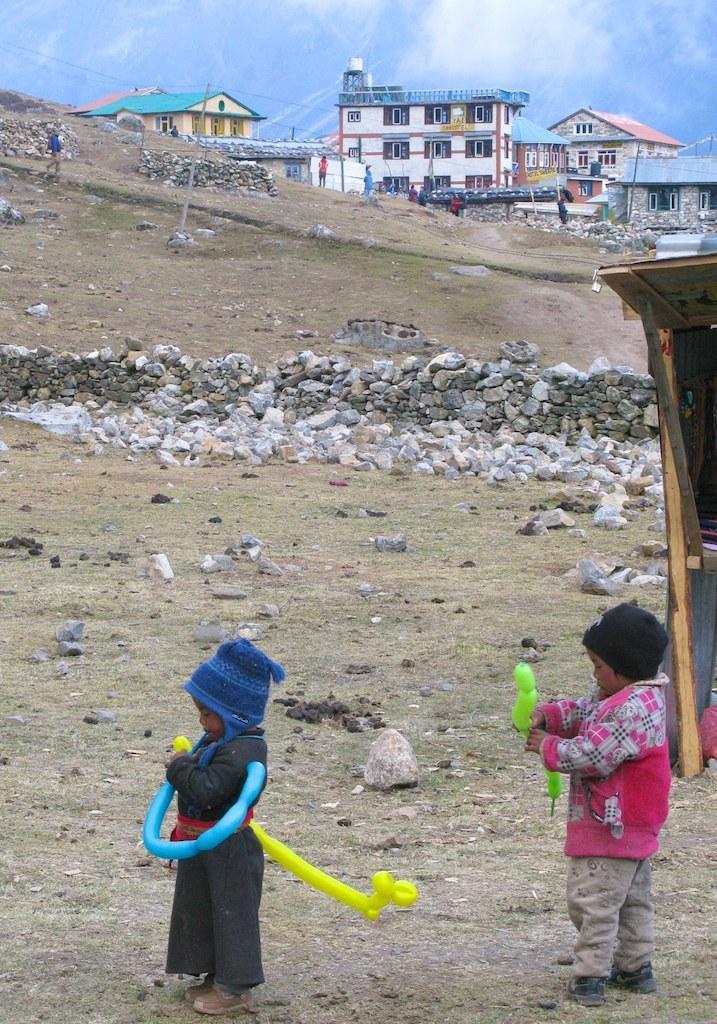Please provide a concise description of this image. In this image in the foreground there are two children who are playing with some toys, and in the background there are some rocks, buildings, poles and some wires. And also there is some grass, on the right side there is one house and at the top of the image there is sky. 